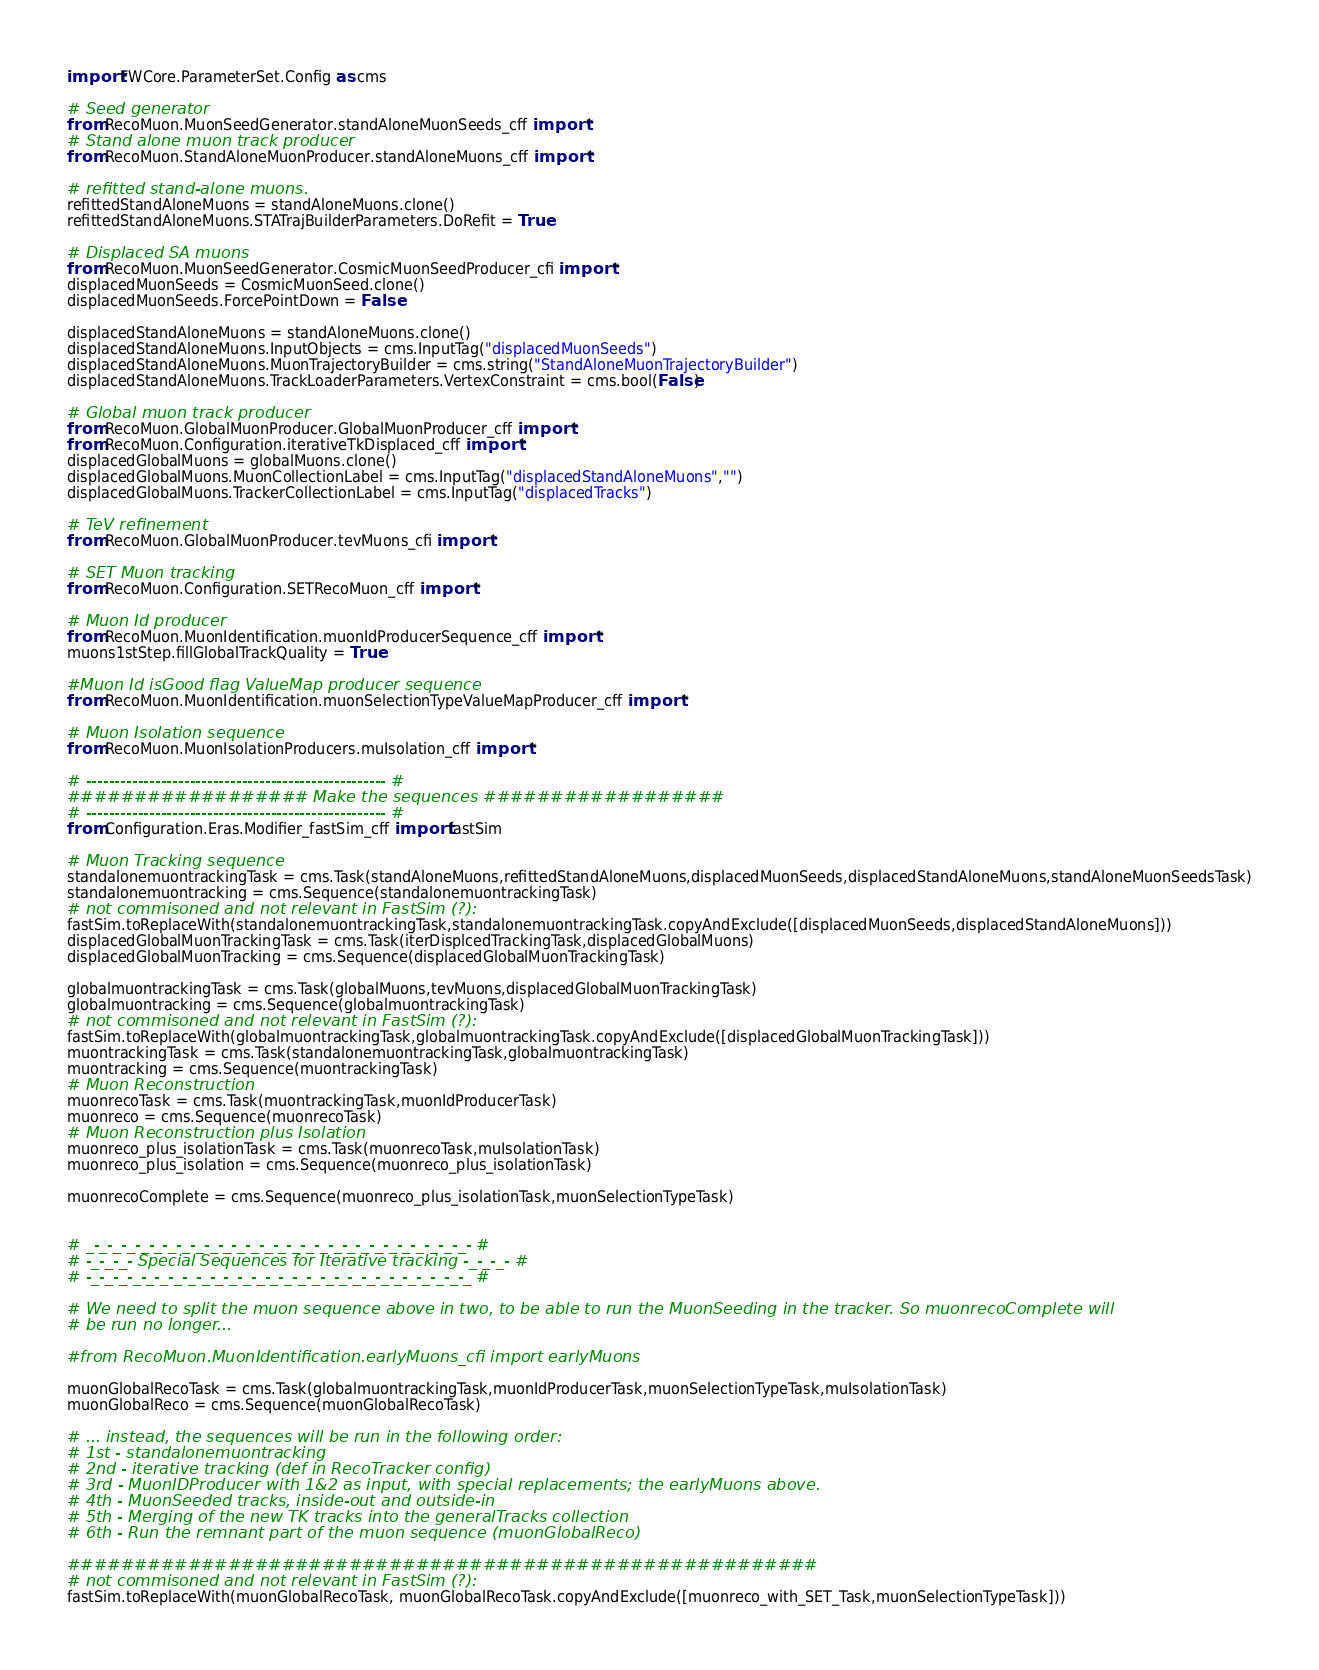<code> <loc_0><loc_0><loc_500><loc_500><_Python_>import FWCore.ParameterSet.Config as cms

# Seed generator
from RecoMuon.MuonSeedGenerator.standAloneMuonSeeds_cff import *
# Stand alone muon track producer
from RecoMuon.StandAloneMuonProducer.standAloneMuons_cff import *

# refitted stand-alone muons.
refittedStandAloneMuons = standAloneMuons.clone()
refittedStandAloneMuons.STATrajBuilderParameters.DoRefit = True

# Displaced SA muons
from RecoMuon.MuonSeedGenerator.CosmicMuonSeedProducer_cfi import *
displacedMuonSeeds = CosmicMuonSeed.clone()
displacedMuonSeeds.ForcePointDown = False

displacedStandAloneMuons = standAloneMuons.clone()
displacedStandAloneMuons.InputObjects = cms.InputTag("displacedMuonSeeds")
displacedStandAloneMuons.MuonTrajectoryBuilder = cms.string("StandAloneMuonTrajectoryBuilder")
displacedStandAloneMuons.TrackLoaderParameters.VertexConstraint = cms.bool(False) 

# Global muon track producer
from RecoMuon.GlobalMuonProducer.GlobalMuonProducer_cff import *
from RecoMuon.Configuration.iterativeTkDisplaced_cff import *
displacedGlobalMuons = globalMuons.clone()
displacedGlobalMuons.MuonCollectionLabel = cms.InputTag("displacedStandAloneMuons","")
displacedGlobalMuons.TrackerCollectionLabel = cms.InputTag("displacedTracks")

# TeV refinement
from RecoMuon.GlobalMuonProducer.tevMuons_cfi import *

# SET Muon tracking
from RecoMuon.Configuration.SETRecoMuon_cff import *

# Muon Id producer
from RecoMuon.MuonIdentification.muonIdProducerSequence_cff import *
muons1stStep.fillGlobalTrackQuality = True

#Muon Id isGood flag ValueMap producer sequence
from RecoMuon.MuonIdentification.muonSelectionTypeValueMapProducer_cff import *

# Muon Isolation sequence
from RecoMuon.MuonIsolationProducers.muIsolation_cff import *

# ---------------------------------------------------- #
################## Make the sequences ##################
# ---------------------------------------------------- #
from Configuration.Eras.Modifier_fastSim_cff import fastSim

# Muon Tracking sequence
standalonemuontrackingTask = cms.Task(standAloneMuons,refittedStandAloneMuons,displacedMuonSeeds,displacedStandAloneMuons,standAloneMuonSeedsTask)
standalonemuontracking = cms.Sequence(standalonemuontrackingTask)
# not commisoned and not relevant in FastSim (?):
fastSim.toReplaceWith(standalonemuontrackingTask,standalonemuontrackingTask.copyAndExclude([displacedMuonSeeds,displacedStandAloneMuons]))
displacedGlobalMuonTrackingTask = cms.Task(iterDisplcedTrackingTask,displacedGlobalMuons)
displacedGlobalMuonTracking = cms.Sequence(displacedGlobalMuonTrackingTask)

globalmuontrackingTask = cms.Task(globalMuons,tevMuons,displacedGlobalMuonTrackingTask)
globalmuontracking = cms.Sequence(globalmuontrackingTask)
# not commisoned and not relevant in FastSim (?):
fastSim.toReplaceWith(globalmuontrackingTask,globalmuontrackingTask.copyAndExclude([displacedGlobalMuonTrackingTask]))
muontrackingTask = cms.Task(standalonemuontrackingTask,globalmuontrackingTask)
muontracking = cms.Sequence(muontrackingTask)
# Muon Reconstruction
muonrecoTask = cms.Task(muontrackingTask,muonIdProducerTask)
muonreco = cms.Sequence(muonrecoTask)
# Muon Reconstruction plus Isolation
muonreco_plus_isolationTask = cms.Task(muonrecoTask,muIsolationTask)
muonreco_plus_isolation = cms.Sequence(muonreco_plus_isolationTask)

muonrecoComplete = cms.Sequence(muonreco_plus_isolationTask,muonSelectionTypeTask)


# _-_-_-_-_-_-_-_-_-_-_-_-_-_-_-_-_-_-_-_-_-_-_-_-_-_-_-_- #
# -_-_-_- Special Sequences for Iterative tracking -_-_-_- #
# -_-_-_-_-_-_-_-_-_-_-_-_-_-_-_-_-_-_-_-_-_-_-_-_-_-_-_-_ #

# We need to split the muon sequence above in two, to be able to run the MuonSeeding in the tracker. So muonrecoComplete will 
# be run no longer...

#from RecoMuon.MuonIdentification.earlyMuons_cfi import earlyMuons

muonGlobalRecoTask = cms.Task(globalmuontrackingTask,muonIdProducerTask,muonSelectionTypeTask,muIsolationTask)
muonGlobalReco = cms.Sequence(muonGlobalRecoTask)

# ... instead, the sequences will be run in the following order:
# 1st - standalonemuontracking
# 2nd - iterative tracking (def in RecoTracker config)
# 3rd - MuonIDProducer with 1&2 as input, with special replacements; the earlyMuons above. 
# 4th - MuonSeeded tracks, inside-out and outside-in
# 5th - Merging of the new TK tracks into the generalTracks collection
# 6th - Run the remnant part of the muon sequence (muonGlobalReco) 

########################################################
# not commisoned and not relevant in FastSim (?):
fastSim.toReplaceWith(muonGlobalRecoTask, muonGlobalRecoTask.copyAndExclude([muonreco_with_SET_Task,muonSelectionTypeTask]))
</code> 